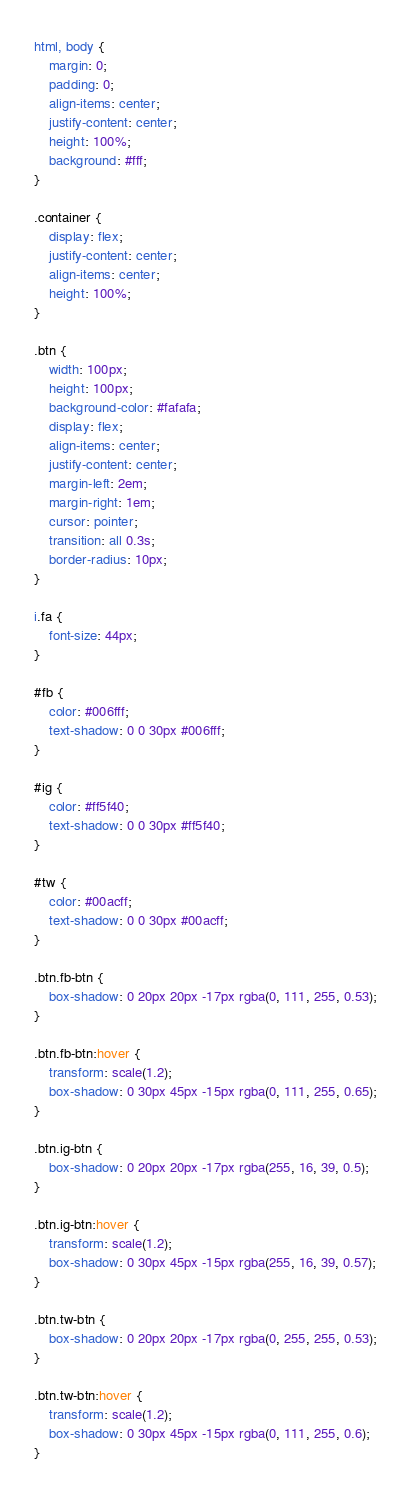Convert code to text. <code><loc_0><loc_0><loc_500><loc_500><_CSS_>html, body {
    margin: 0;
    padding: 0;
    align-items: center;
    justify-content: center;
    height: 100%;
    background: #fff;
}

.container {
    display: flex;
    justify-content: center;
    align-items: center;
    height: 100%;
}

.btn {
    width: 100px;
    height: 100px;
    background-color: #fafafa;
    display: flex;
    align-items: center;
    justify-content: center;
    margin-left: 2em;
    margin-right: 1em;
    cursor: pointer;
    transition: all 0.3s;
    border-radius: 10px;
}

i.fa {
    font-size: 44px;
}

#fb {
    color: #006fff;
    text-shadow: 0 0 30px #006fff;
}

#ig {
    color: #ff5f40;
    text-shadow: 0 0 30px #ff5f40;
}

#tw {
    color: #00acff;
    text-shadow: 0 0 30px #00acff;
}

.btn.fb-btn {
    box-shadow: 0 20px 20px -17px rgba(0, 111, 255, 0.53);
}

.btn.fb-btn:hover {
    transform: scale(1.2);
    box-shadow: 0 30px 45px -15px rgba(0, 111, 255, 0.65);
}

.btn.ig-btn {
    box-shadow: 0 20px 20px -17px rgba(255, 16, 39, 0.5);
}

.btn.ig-btn:hover {
    transform: scale(1.2);
    box-shadow: 0 30px 45px -15px rgba(255, 16, 39, 0.57);
}

.btn.tw-btn {
    box-shadow: 0 20px 20px -17px rgba(0, 255, 255, 0.53);
}

.btn.tw-btn:hover {
    transform: scale(1.2);
    box-shadow: 0 30px 45px -15px rgba(0, 111, 255, 0.6);
}</code> 